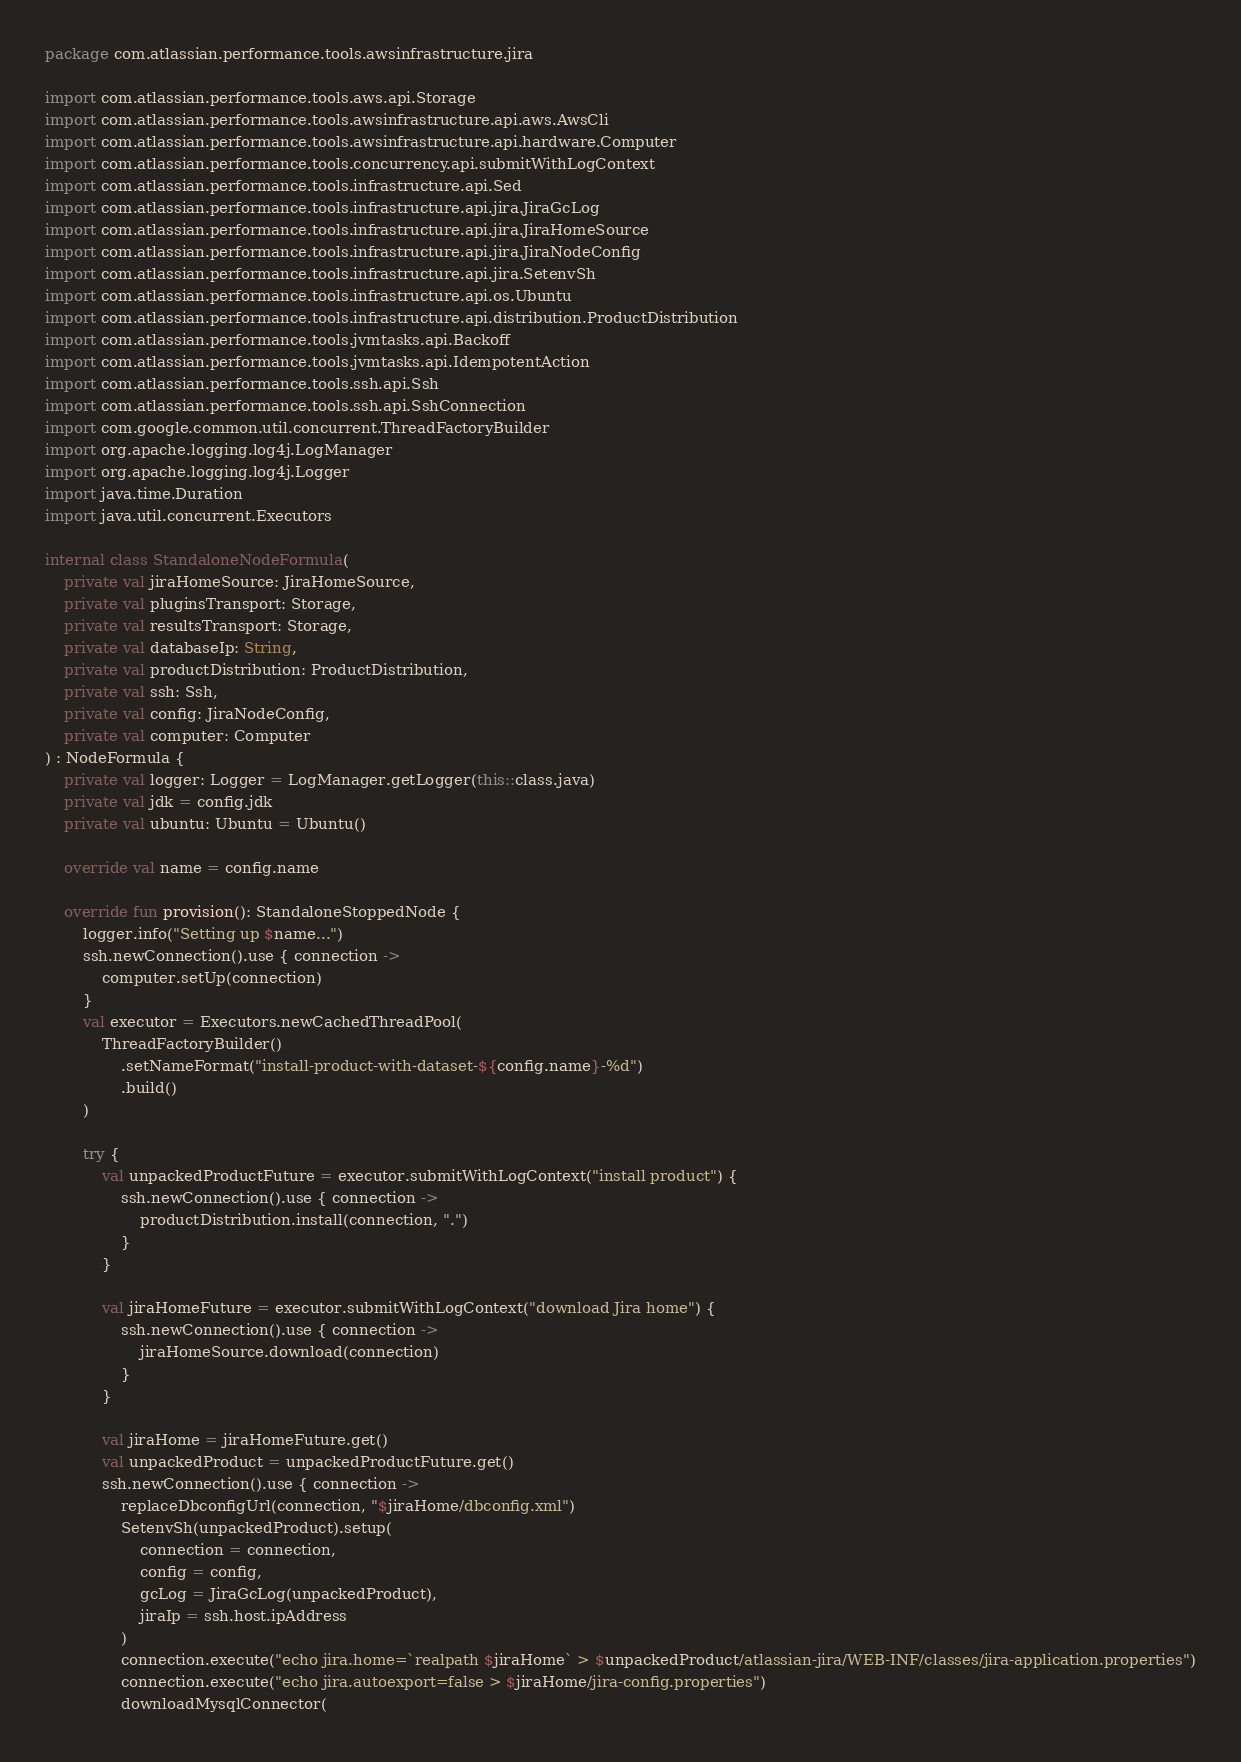<code> <loc_0><loc_0><loc_500><loc_500><_Kotlin_>package com.atlassian.performance.tools.awsinfrastructure.jira

import com.atlassian.performance.tools.aws.api.Storage
import com.atlassian.performance.tools.awsinfrastructure.api.aws.AwsCli
import com.atlassian.performance.tools.awsinfrastructure.api.hardware.Computer
import com.atlassian.performance.tools.concurrency.api.submitWithLogContext
import com.atlassian.performance.tools.infrastructure.api.Sed
import com.atlassian.performance.tools.infrastructure.api.jira.JiraGcLog
import com.atlassian.performance.tools.infrastructure.api.jira.JiraHomeSource
import com.atlassian.performance.tools.infrastructure.api.jira.JiraNodeConfig
import com.atlassian.performance.tools.infrastructure.api.jira.SetenvSh
import com.atlassian.performance.tools.infrastructure.api.os.Ubuntu
import com.atlassian.performance.tools.infrastructure.api.distribution.ProductDistribution
import com.atlassian.performance.tools.jvmtasks.api.Backoff
import com.atlassian.performance.tools.jvmtasks.api.IdempotentAction
import com.atlassian.performance.tools.ssh.api.Ssh
import com.atlassian.performance.tools.ssh.api.SshConnection
import com.google.common.util.concurrent.ThreadFactoryBuilder
import org.apache.logging.log4j.LogManager
import org.apache.logging.log4j.Logger
import java.time.Duration
import java.util.concurrent.Executors

internal class StandaloneNodeFormula(
    private val jiraHomeSource: JiraHomeSource,
    private val pluginsTransport: Storage,
    private val resultsTransport: Storage,
    private val databaseIp: String,
    private val productDistribution: ProductDistribution,
    private val ssh: Ssh,
    private val config: JiraNodeConfig,
    private val computer: Computer
) : NodeFormula {
    private val logger: Logger = LogManager.getLogger(this::class.java)
    private val jdk = config.jdk
    private val ubuntu: Ubuntu = Ubuntu()

    override val name = config.name

    override fun provision(): StandaloneStoppedNode {
        logger.info("Setting up $name...")
        ssh.newConnection().use { connection ->
            computer.setUp(connection)
        }
        val executor = Executors.newCachedThreadPool(
            ThreadFactoryBuilder()
                .setNameFormat("install-product-with-dataset-${config.name}-%d")
                .build()
        )

        try {
            val unpackedProductFuture = executor.submitWithLogContext("install product") {
                ssh.newConnection().use { connection ->
                    productDistribution.install(connection, ".")
                }
            }

            val jiraHomeFuture = executor.submitWithLogContext("download Jira home") {
                ssh.newConnection().use { connection ->
                    jiraHomeSource.download(connection)
                }
            }

            val jiraHome = jiraHomeFuture.get()
            val unpackedProduct = unpackedProductFuture.get()
            ssh.newConnection().use { connection ->
                replaceDbconfigUrl(connection, "$jiraHome/dbconfig.xml")
                SetenvSh(unpackedProduct).setup(
                    connection = connection,
                    config = config,
                    gcLog = JiraGcLog(unpackedProduct),
                    jiraIp = ssh.host.ipAddress
                )
                connection.execute("echo jira.home=`realpath $jiraHome` > $unpackedProduct/atlassian-jira/WEB-INF/classes/jira-application.properties")
                connection.execute("echo jira.autoexport=false > $jiraHome/jira-config.properties")
                downloadMysqlConnector(</code> 